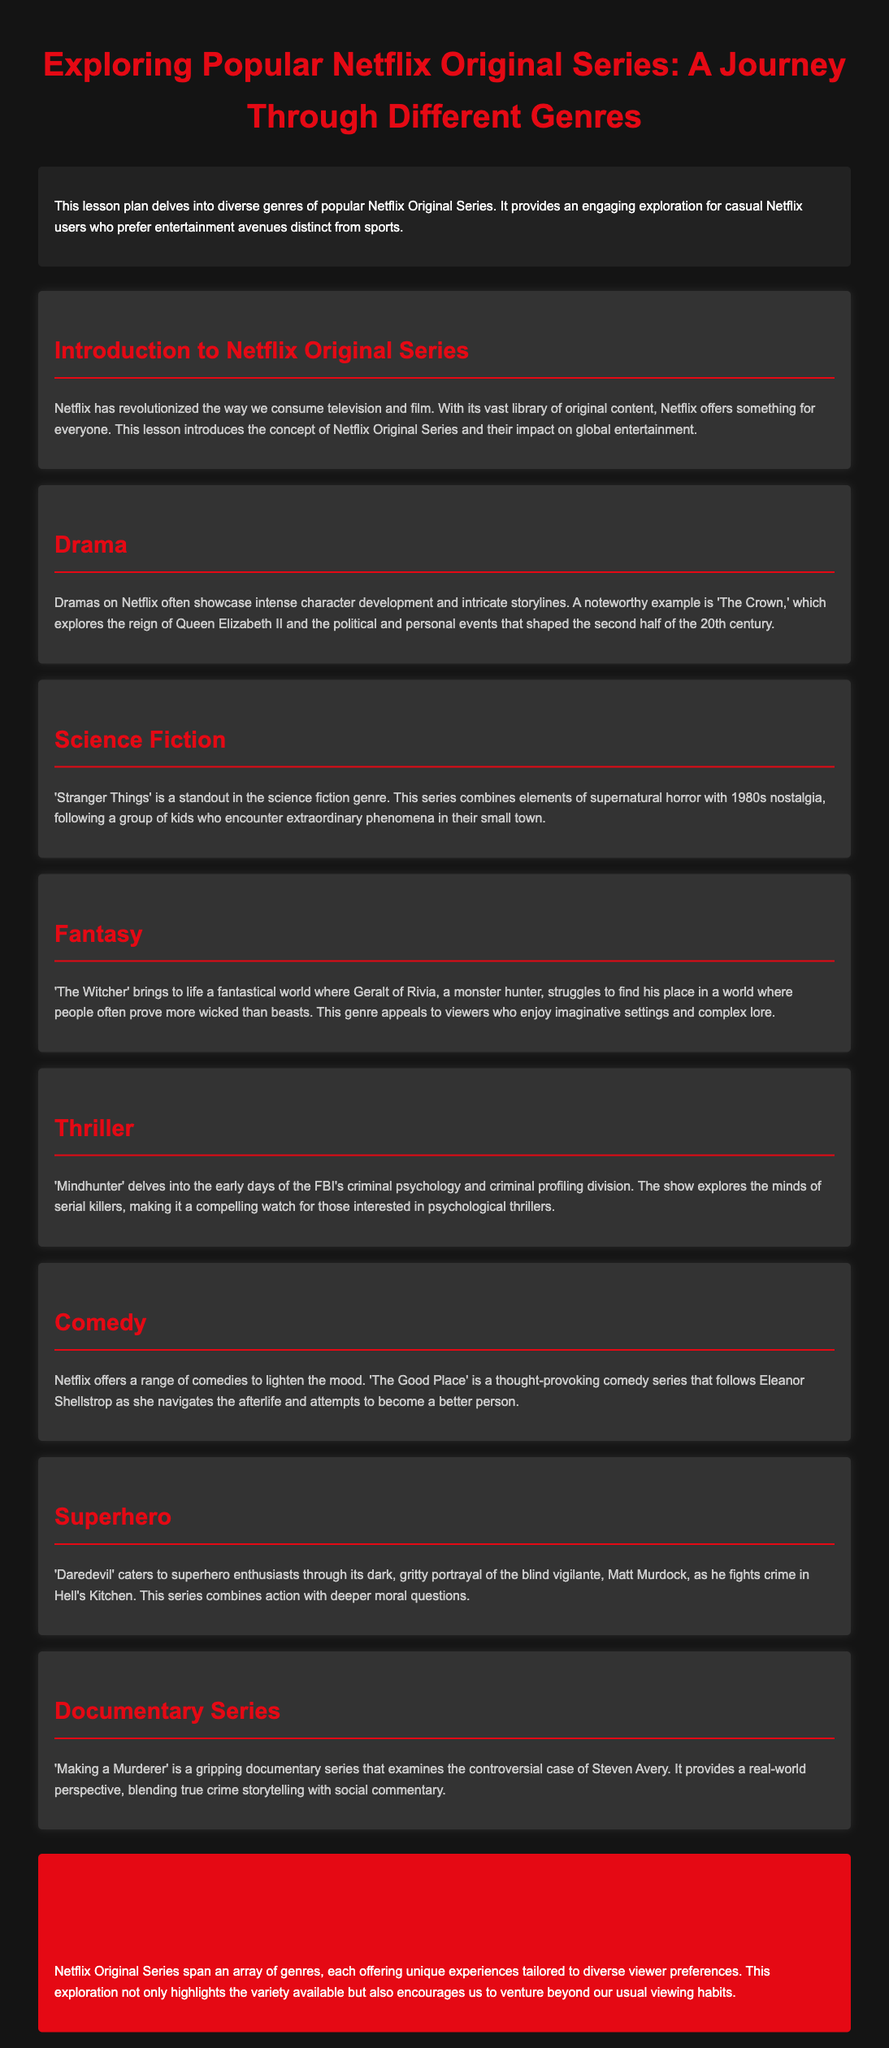What is the title of the lesson plan? The title of the lesson plan is "Exploring Popular Netflix Original Series: A Journey Through Different Genres."
Answer: Exploring Popular Netflix Original Series: A Journey Through Different Genres Which series explores the reign of Queen Elizabeth II? The series that explores the reign of Queen Elizabeth II is mentioned under the Drama section.
Answer: The Crown What genre is 'Stranger Things' associated with? 'Stranger Things' is highlighted in the Science Fiction section of the document.
Answer: Science Fiction Which series follows Eleanor Shellstrop in the afterlife? This series is detailed in the Comedy section, mentioning the character's journey.
Answer: The Good Place What type of series is 'Making a Murderer'? The document specifies the nature of 'Making a Murderer' in the Documentary Series section.
Answer: Documentary Series Name one theme explored in 'Mindhunter'. The document indicates that 'Mindhunter' delves into criminal psychology and profiling.
Answer: Criminal psychology Which genre includes 'Daredevil'? 'Daredevil' is categorized under the Superhero genre in the document.
Answer: Superhero Identify one characteristic of dramas on Netflix. The characteristics of dramas are described in the Drama section, emphasizing character development.
Answer: Intense character development What does the conclusion emphasize about Netflix Original Series? The conclusion explains the variety offered by Netflix Original Series and encourages exploration beyond usual habits.
Answer: Variety and exploration 